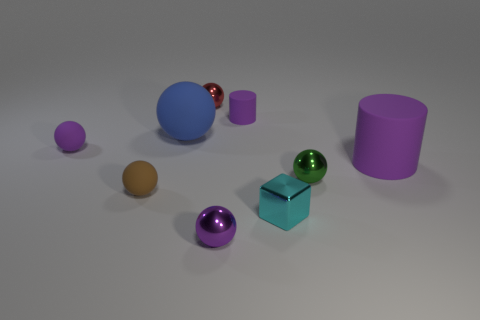Subtract all tiny green shiny balls. How many balls are left? 5 Add 1 blue balls. How many objects exist? 10 Subtract all blocks. How many objects are left? 8 Subtract 1 cylinders. How many cylinders are left? 1 Add 9 red shiny balls. How many red shiny balls are left? 10 Add 6 large cylinders. How many large cylinders exist? 7 Subtract all green spheres. How many spheres are left? 5 Subtract 0 yellow spheres. How many objects are left? 9 Subtract all green cubes. Subtract all purple cylinders. How many cubes are left? 1 Subtract all gray cylinders. How many green blocks are left? 0 